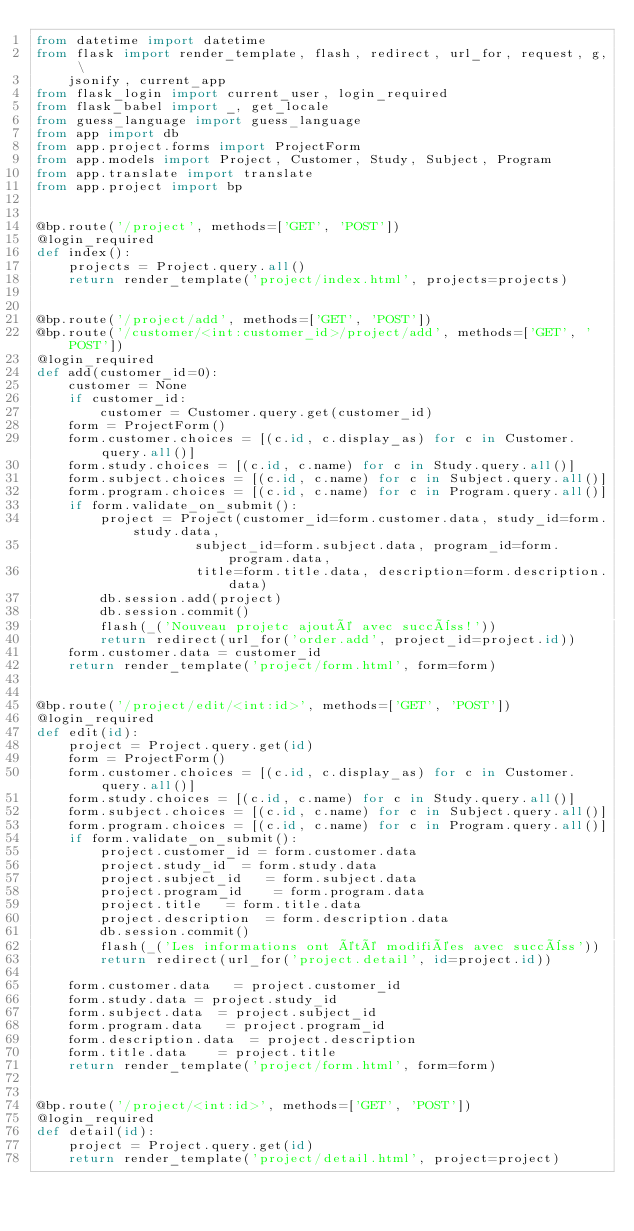<code> <loc_0><loc_0><loc_500><loc_500><_Python_>from datetime import datetime
from flask import render_template, flash, redirect, url_for, request, g, \
    jsonify, current_app
from flask_login import current_user, login_required
from flask_babel import _, get_locale
from guess_language import guess_language
from app import db
from app.project.forms import ProjectForm
from app.models import Project, Customer, Study, Subject, Program
from app.translate import translate
from app.project import bp


@bp.route('/project', methods=['GET', 'POST'])
@login_required
def index():
    projects = Project.query.all()
    return render_template('project/index.html', projects=projects)


@bp.route('/project/add', methods=['GET', 'POST'])
@bp.route('/customer/<int:customer_id>/project/add', methods=['GET', 'POST'])
@login_required
def add(customer_id=0):
    customer = None
    if customer_id:
        customer = Customer.query.get(customer_id)
    form = ProjectForm()
    form.customer.choices = [(c.id, c.display_as) for c in Customer.query.all()]
    form.study.choices = [(c.id, c.name) for c in Study.query.all()]
    form.subject.choices = [(c.id, c.name) for c in Subject.query.all()]
    form.program.choices = [(c.id, c.name) for c in Program.query.all()]
    if form.validate_on_submit():
        project = Project(customer_id=form.customer.data, study_id=form.study.data,
                    subject_id=form.subject.data, program_id=form.program.data,
                    title=form.title.data, description=form.description.data)
        db.session.add(project)
        db.session.commit()
        flash(_('Nouveau projetc ajouté avec succèss!'))
        return redirect(url_for('order.add', project_id=project.id))
    form.customer.data = customer_id
    return render_template('project/form.html', form=form)


@bp.route('/project/edit/<int:id>', methods=['GET', 'POST'])
@login_required
def edit(id):
    project = Project.query.get(id)
    form = ProjectForm()
    form.customer.choices = [(c.id, c.display_as) for c in Customer.query.all()]
    form.study.choices = [(c.id, c.name) for c in Study.query.all()]
    form.subject.choices = [(c.id, c.name) for c in Subject.query.all()]
    form.program.choices = [(c.id, c.name) for c in Program.query.all()]
    if form.validate_on_submit():
        project.customer_id = form.customer.data
        project.study_id  = form.study.data
        project.subject_id   = form.subject.data
        project.program_id    = form.program.data
        project.title   = form.title.data
        project.description  = form.description.data
        db.session.commit()
        flash(_('Les informations ont été modifiées avec succèss'))
        return redirect(url_for('project.detail', id=project.id))

    form.customer.data   = project.customer_id
    form.study.data = project.study_id
    form.subject.data  = project.subject_id
    form.program.data   = project.program_id
    form.description.data  = project.description
    form.title.data    = project.title
    return render_template('project/form.html', form=form)


@bp.route('/project/<int:id>', methods=['GET', 'POST'])
@login_required
def detail(id):
    project = Project.query.get(id)
    return render_template('project/detail.html', project=project)
</code> 